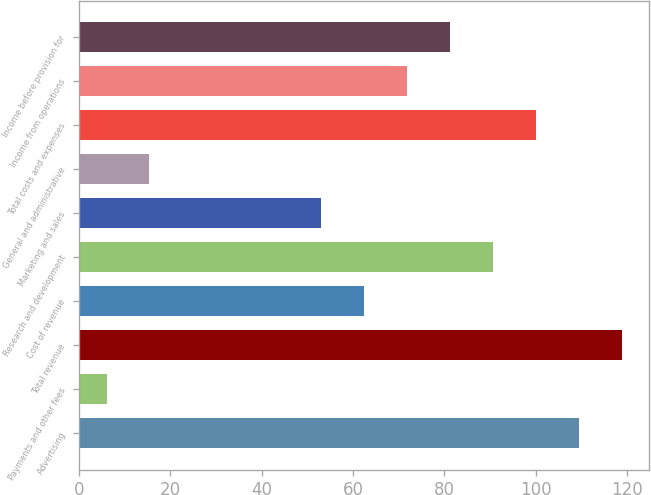Convert chart. <chart><loc_0><loc_0><loc_500><loc_500><bar_chart><fcel>Advertising<fcel>Payments and other fees<fcel>Total revenue<fcel>Cost of revenue<fcel>Research and development<fcel>Marketing and sales<fcel>General and administrative<fcel>Total costs and expenses<fcel>Income from operations<fcel>Income before provision for<nl><fcel>109.4<fcel>6<fcel>118.8<fcel>62.4<fcel>90.6<fcel>53<fcel>15.4<fcel>100<fcel>71.8<fcel>81.2<nl></chart> 